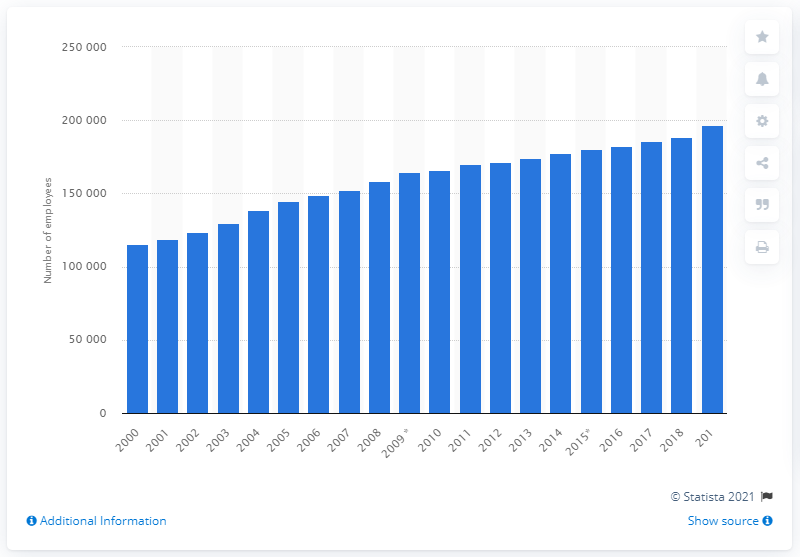Give some essential details in this illustration. In 2019, there were 196,784 healthcare physicians employed in the United Kingdom. 